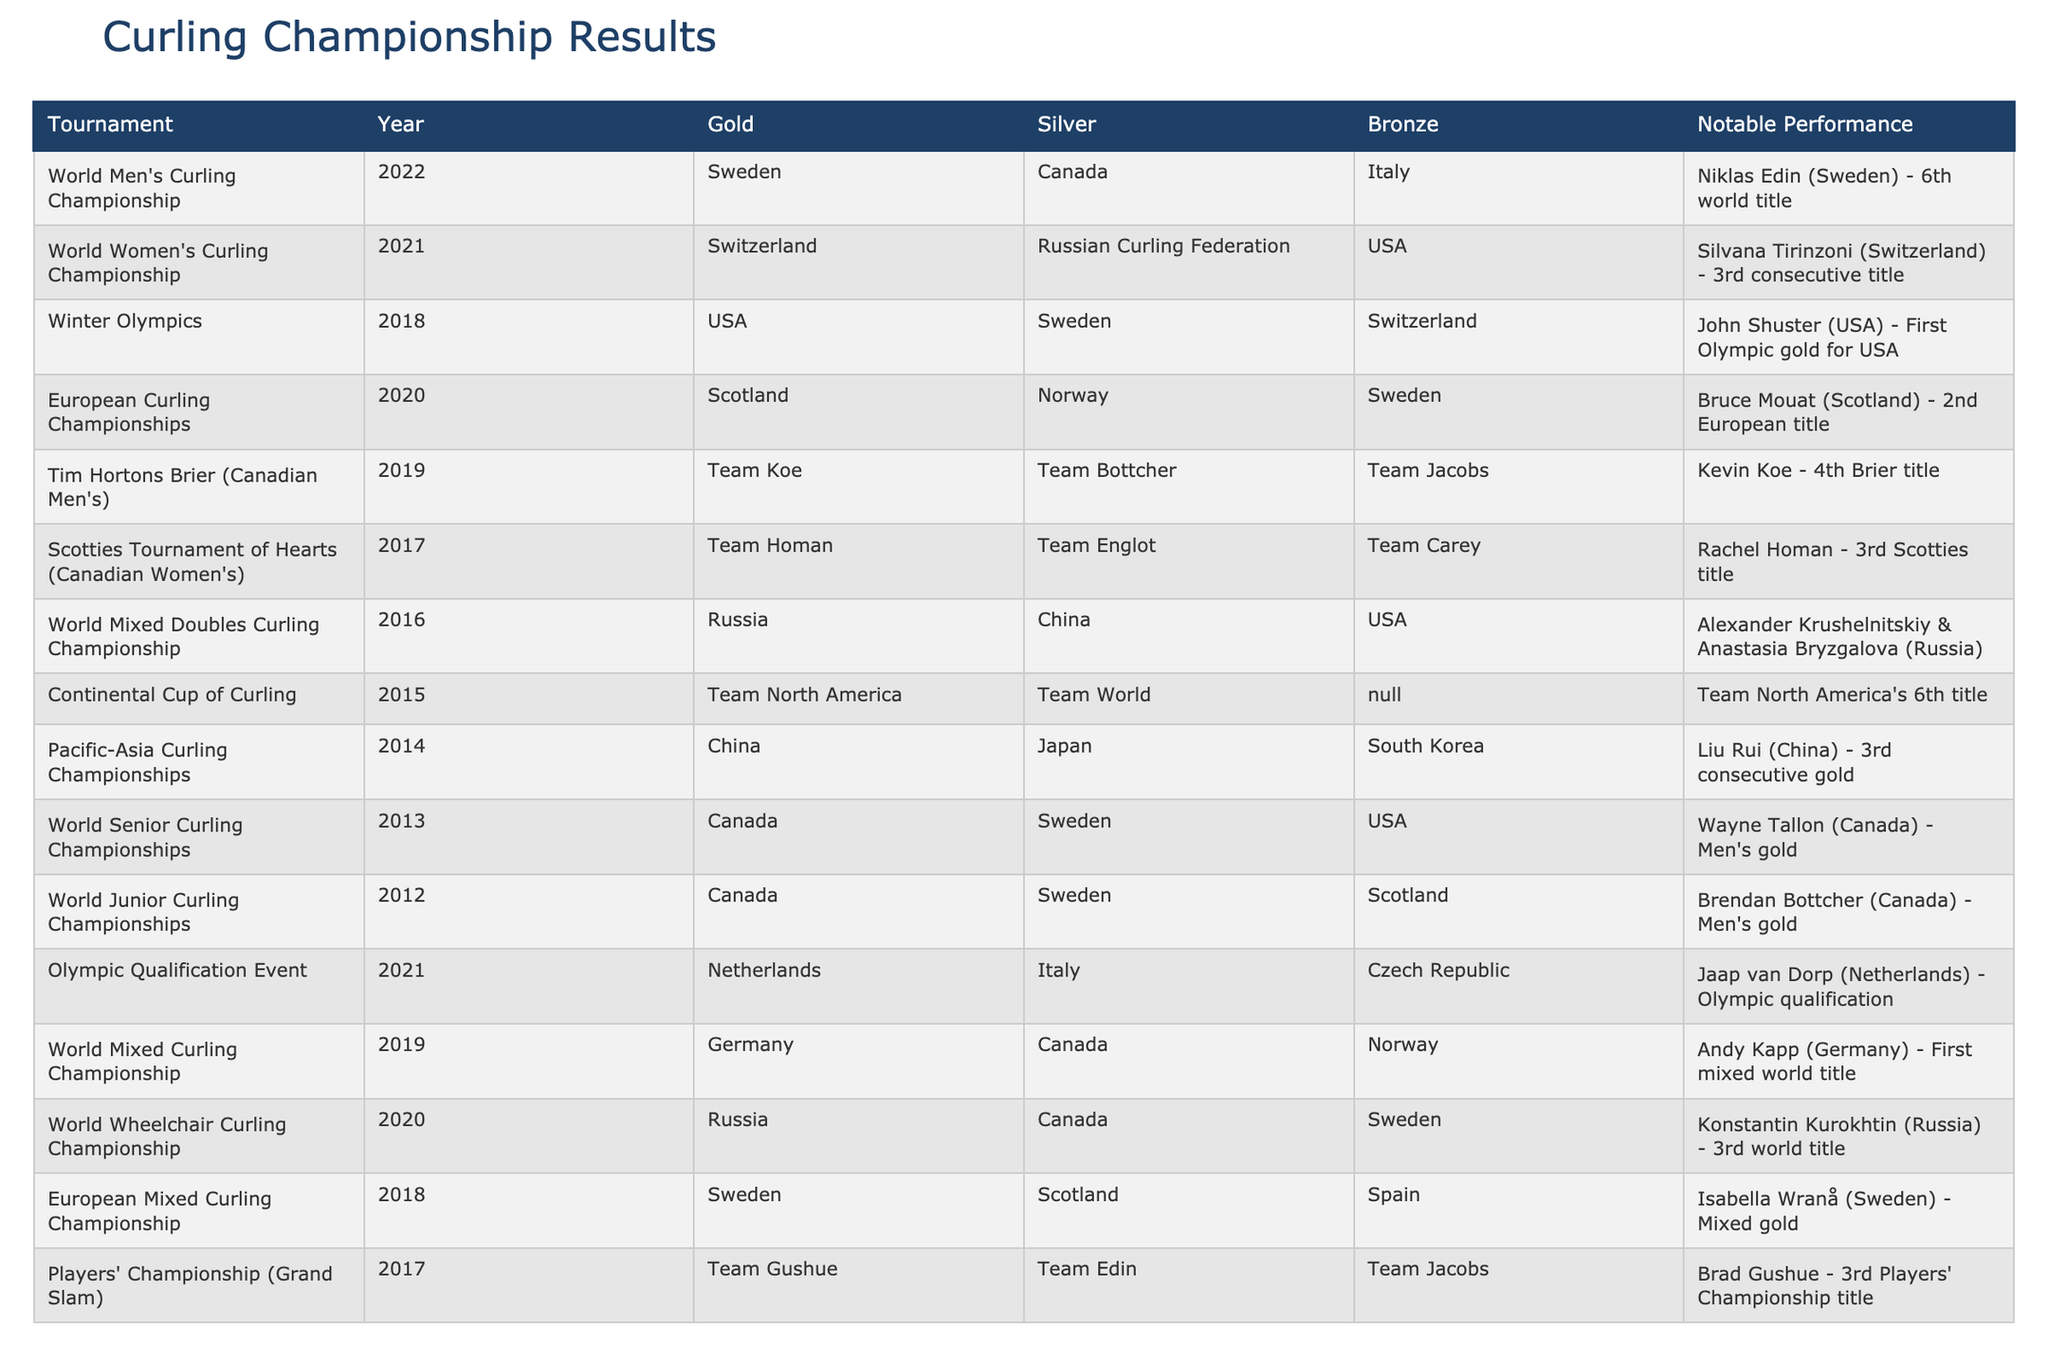What country won the gold medal in the 2022 World Men's Curling Championship? The table indicates that Sweden won the gold medal at the 2022 World Men's Curling Championship.
Answer: Sweden Which country secured second place in the 2021 World Women's Curling Championship? According to the table, the Russian Curling Federation finished in silver position in the 2021 World Women's Curling Championship.
Answer: Russian Curling Federation How many total tournaments are listed in the table? There are 10 tournaments presented in the table, counting each row that represents a different championship result.
Answer: 10 Did the USA win any gold medals in the Winter Olympics in 2018? Yes, the table shows that the USA won the gold medal in the Winter Olympics in 2018.
Answer: Yes Which country has the most notable performances listed? By reviewing the notable performances column, Sweden appears multiple times (in 2022, 2018, and 2016), indicating it has the most notable performances listed in the table.
Answer: Sweden What is the difference in the number of gold medals won by Canada in 2012 and 2013? Canada won 1 gold medal in both 2012 and 2013, so the difference is 1 - 1 = 0.
Answer: 0 Which country has the most recent win in the World Mixed Curling Championship from the data provided? The table lists that Germany won the World Mixed Curling Championship in 2019, which is the most recent win among the tournaments provided.
Answer: Germany Was there a tournament in which no bronze medal was awarded? Yes, the Continental Cup of Curling in 2015 does not have a bronze medal awarded, as indicated by the N/A in the bronze column.
Answer: Yes What is the average position of Team Homan in major tournaments specified, given their results? Team Homan secured a gold in 2017 and there are no other entries listed in the table, so their average position is calculated as (1) since gold corresponds to the first position.
Answer: 1 